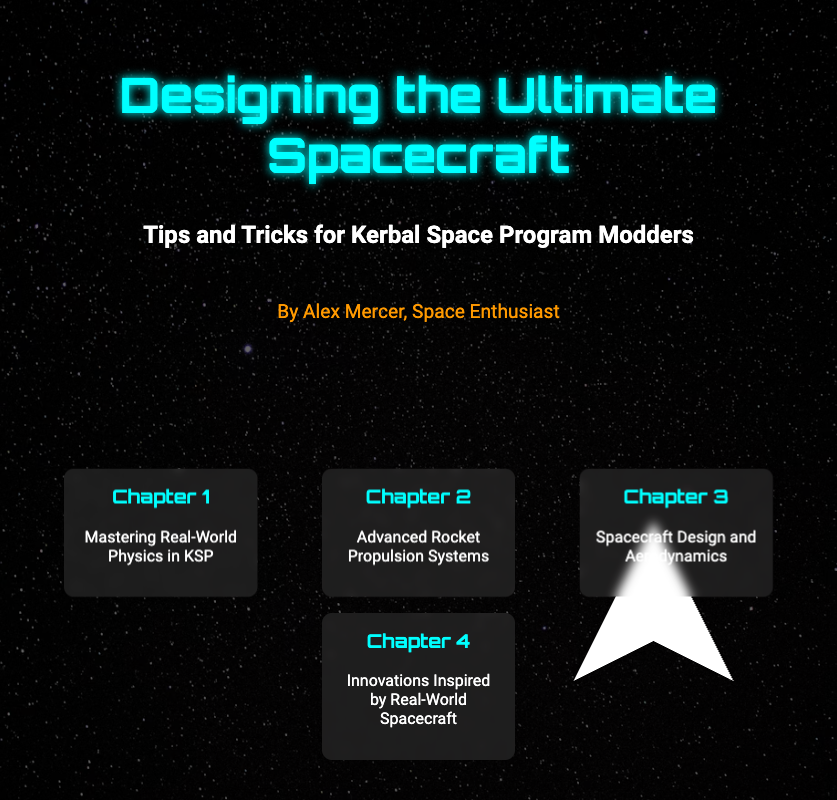What is the title of the book? The title is prominently displayed at the top of the cover.
Answer: Designing the Ultimate Spacecraft Who is the author of the book? The author's name is mentioned below the title.
Answer: Alex Mercer What is the subtitle of the book? The subtitle is located beneath the title, providing more context.
Answer: Tips and Tricks for Kerbal Space Program Modders How many chapters are listed on the book cover? The number of chapters can be counted from the chapters section.
Answer: 4 What is the focus of Chapter 1? The chapter title provides insight into its main theme.
Answer: Mastering Real-World Physics in KSP What type of book is this? The format and content indicate this is a specific genre.
Answer: Guidebook What design element is used to enhance the cover? The cover features a specific visual element at the bottom right.
Answer: Spacecraft What background color is used for the book cover? The overall color scheme is visible throughout the document.
Answer: Black What type of graphics is used in the spacecraft image? The description of the image helps identify its style.
Answer: SVG graphic 